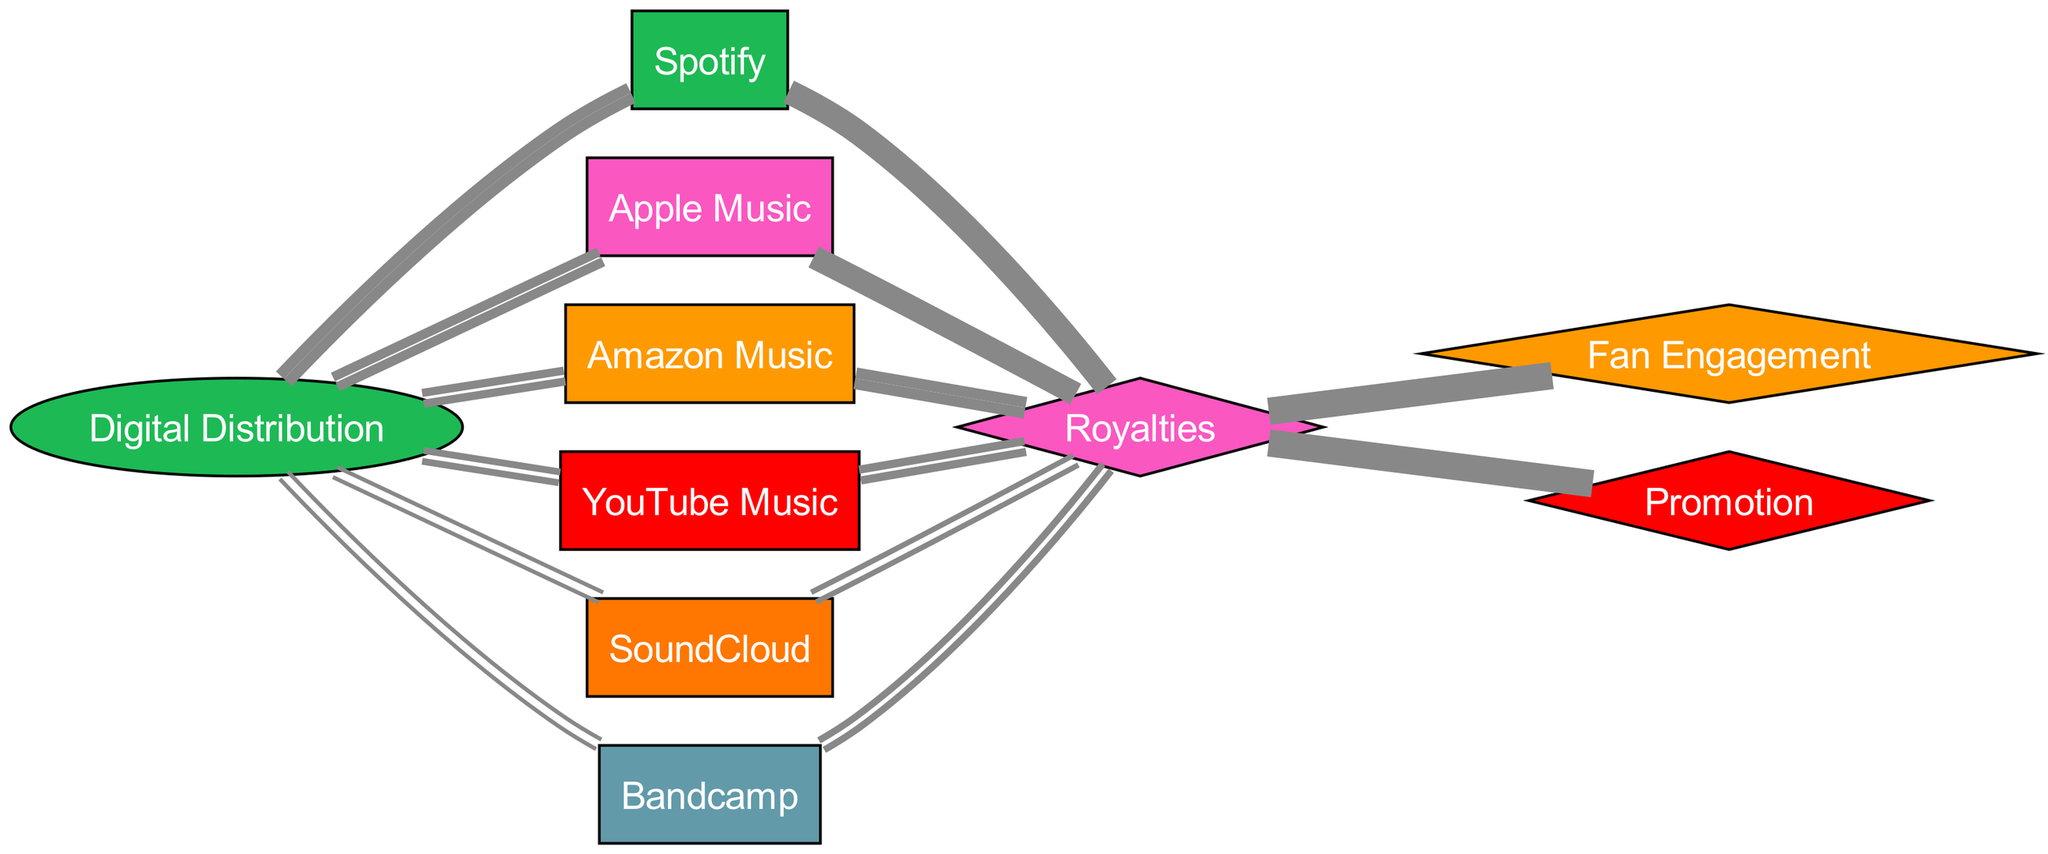What is the total distribution value from Digital Distribution to all platforms? To obtain the total distribution value, sum the values of the links originating from the Digital Distribution node: 30 (Spotify) + 25 (Apple Music) + 20 (Amazon Music) + 15 (YouTube Music) + 5 (SoundCloud) + 5 (Bandcamp) = 100.
Answer: 100 Which platform receives the highest distribution value? By comparing the distribution values from Digital Distribution to each platform, the highest value is for Spotify with a value of 30.
Answer: Spotify What is the revenue generated from Apple Music? The revenue generated specifically from Apple Music, as indicated by the link from Apple Music to Royalties, is 35.
Answer: 35 How many total nodes are represented in this diagram? Count all nodes listed in the data: there are 6 platforms, 1 service, and 2 revenue outcomes, totaling 9 nodes.
Answer: 9 What is the value transferred from Royalties to Fan Engagement? The value of the link from Royalties to Fan Engagement is 50, as indicated in the diagram's links.
Answer: 50 How does Bandcamp contribute to the total royalties? The value transferred from Bandcamp to Royalties is 15, which indicates Bandcamp's contribution to the overall royalty generation.
Answer: 15 What percentage of total distribution value does Amazon Music receive? Amazon Music receives a distribution value of 20 out of the total distribution value of 100. Therefore, the percentage is (20/100)*100 = 20%.
Answer: 20% Which outcome receives an equal share of revenue from Royalties? Both Fan Engagement and Promotion receive an equal share of 50 from the Royalties, indicating an equal distribution between these outcomes.
Answer: Fan Engagement, Promotion What is the connection type between Digital Distribution and its platforms? The connections between Digital Distribution and its platforms are all directed edges, indicating a flow of values from Digital Distribution to each streaming platform.
Answer: Directed edges 